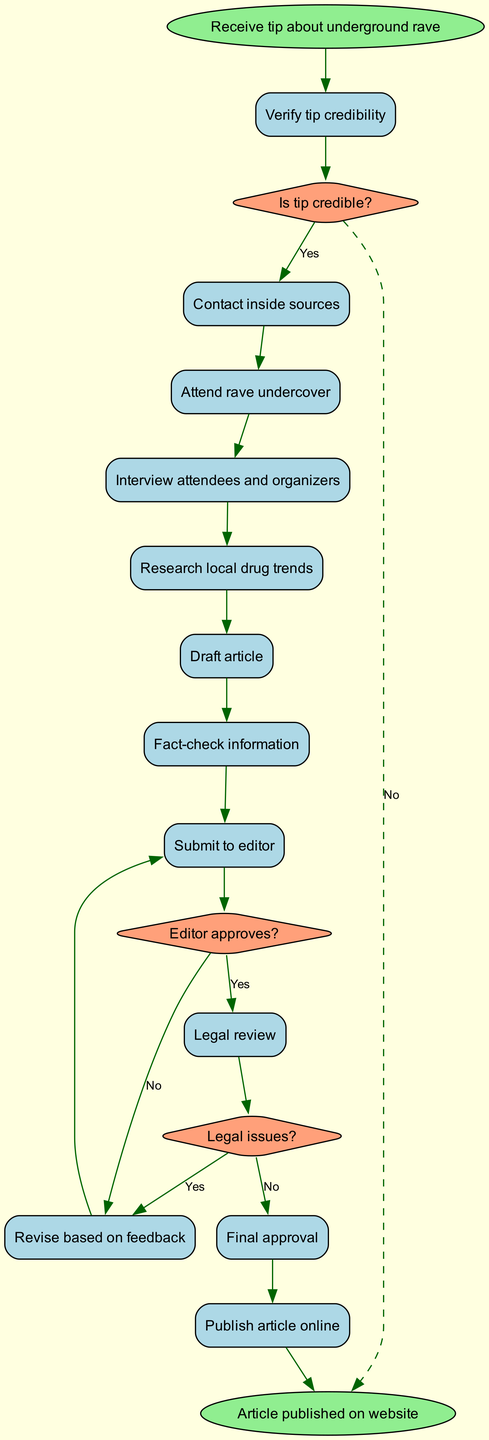What is the initial state of the diagram? The initial state is indicated by the oval node at the top of the diagram, labeled "Receive tip about underground rave".
Answer: Receive tip about underground rave How many activities are there in the workflow? The diagram lists ten activities in the workflow, numbered from act_0 to act_9.
Answer: 10 What is the last activity before the legal review? The activity that comes just before the legal review is "Revise based on feedback," connected to it with an edge from the decision node labeled "Editor approves?".
Answer: Revise based on feedback If the tip is not credible, what is the next step? According to the decision node "Is tip credible?", a "No" answer leads directly to the end of the investigation, as indicated by the dashed edge to "End investigation".
Answer: End investigation What happens if there are legal issues after the legal review? If legal issues arise, the workflow returns to "Revise based on feedback", as indicated by the decision node "Legal issues?" connecting it back to this activity.
Answer: Revise based on feedback How many decision nodes are present in the diagram? The diagram contains three decision nodes, each representing a decision point in the workflow: "Is tip credible?", "Editor approves?", and "Legal issues?".
Answer: 3 What is the final state of the workflow? The final state is indicated by the last oval node in the diagram, labeled "Article published on website".
Answer: Article published on website What is the activity immediately following "Draft article"? The activity that immediately follows "Draft article" is "Fact-check information", as shown by the directed edge that connects them in sequence.
Answer: Fact-check information What happens if the editor does not approve the article? If the editor does not approve the article, the workflow leads to "Revise based on feedback", as indicated by the outgoing edge labeled "No" from the decision node "Editor approves?".
Answer: Revise based on feedback 